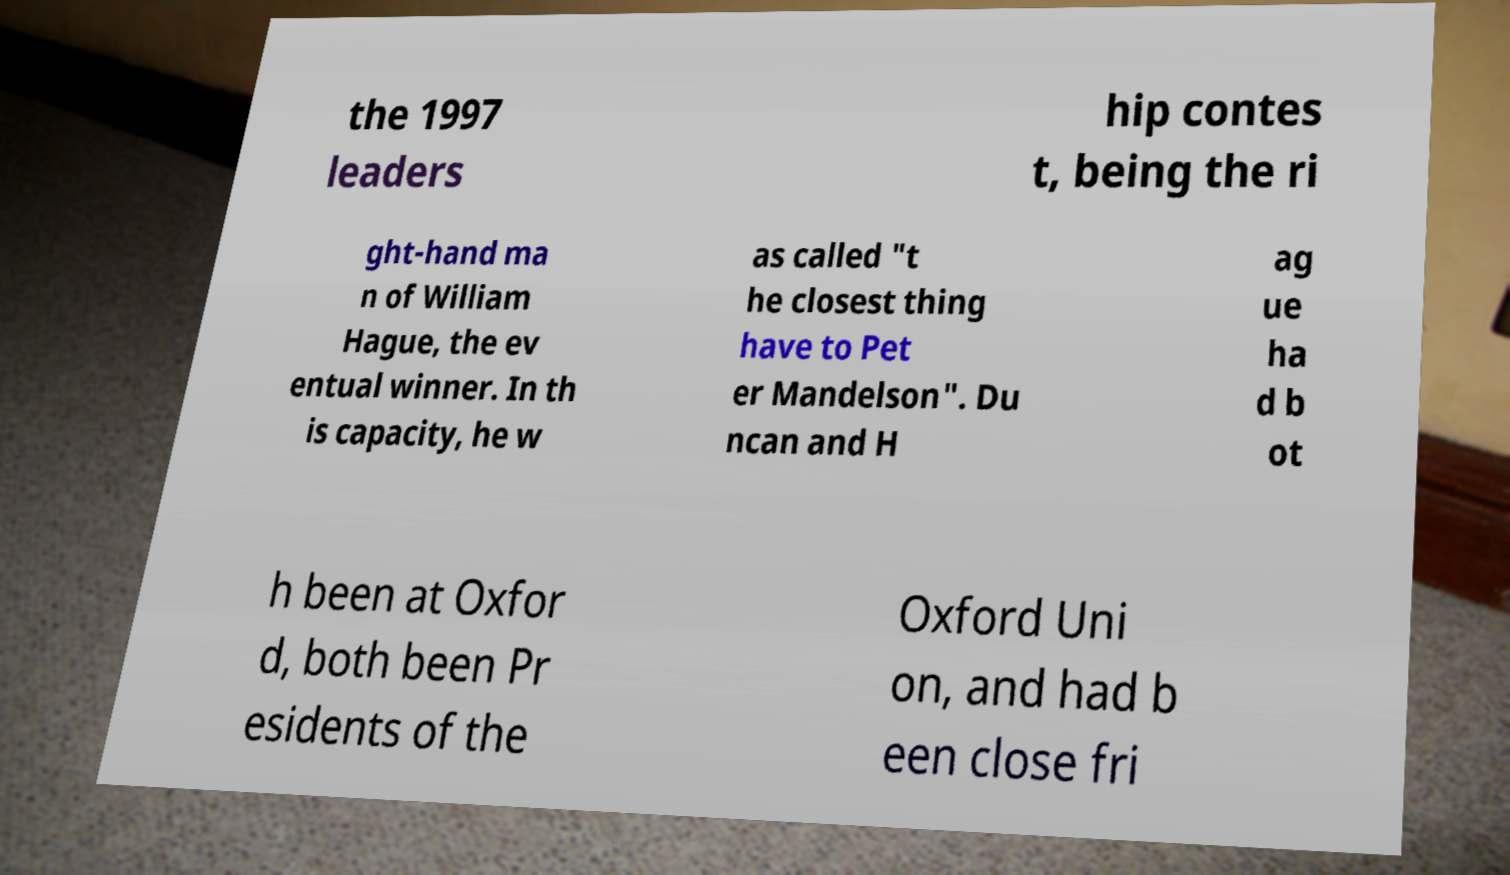Could you assist in decoding the text presented in this image and type it out clearly? the 1997 leaders hip contes t, being the ri ght-hand ma n of William Hague, the ev entual winner. In th is capacity, he w as called "t he closest thing have to Pet er Mandelson". Du ncan and H ag ue ha d b ot h been at Oxfor d, both been Pr esidents of the Oxford Uni on, and had b een close fri 